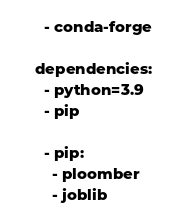<code> <loc_0><loc_0><loc_500><loc_500><_YAML_>  - conda-forge

dependencies:
  - python=3.9
  - pip

  - pip:
    - ploomber
    - joblib

</code> 